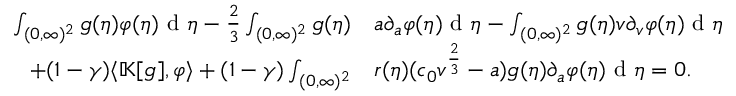Convert formula to latex. <formula><loc_0><loc_0><loc_500><loc_500>\begin{array} { r l } { \int _ { ( 0 , \infty ) ^ { 2 } } g ( \eta ) \varphi ( \eta ) d \eta - \frac { 2 } { 3 } \int _ { ( 0 , \infty ) ^ { 2 } } g ( \eta ) } & { a \partial _ { a } \varphi ( \eta ) d \eta - \int _ { ( 0 , \infty ) ^ { 2 } } g ( \eta ) v \partial _ { v } \varphi ( \eta ) d \eta } \\ { + ( 1 - \gamma ) \langle \mathbb { K } [ g ] , \varphi \rangle + ( 1 - \gamma ) \int _ { ( 0 , \infty ) ^ { 2 } } } & { r ( \eta ) ( c _ { 0 } v ^ { \frac { 2 } { 3 } } - a ) g ( \eta ) \partial _ { a } \varphi ( \eta ) d \eta = 0 . } \end{array}</formula> 